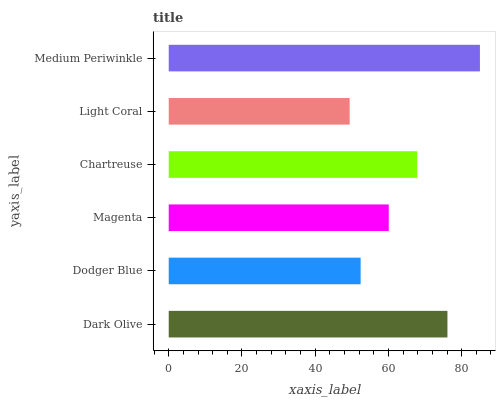Is Light Coral the minimum?
Answer yes or no. Yes. Is Medium Periwinkle the maximum?
Answer yes or no. Yes. Is Dodger Blue the minimum?
Answer yes or no. No. Is Dodger Blue the maximum?
Answer yes or no. No. Is Dark Olive greater than Dodger Blue?
Answer yes or no. Yes. Is Dodger Blue less than Dark Olive?
Answer yes or no. Yes. Is Dodger Blue greater than Dark Olive?
Answer yes or no. No. Is Dark Olive less than Dodger Blue?
Answer yes or no. No. Is Chartreuse the high median?
Answer yes or no. Yes. Is Magenta the low median?
Answer yes or no. Yes. Is Dodger Blue the high median?
Answer yes or no. No. Is Dodger Blue the low median?
Answer yes or no. No. 